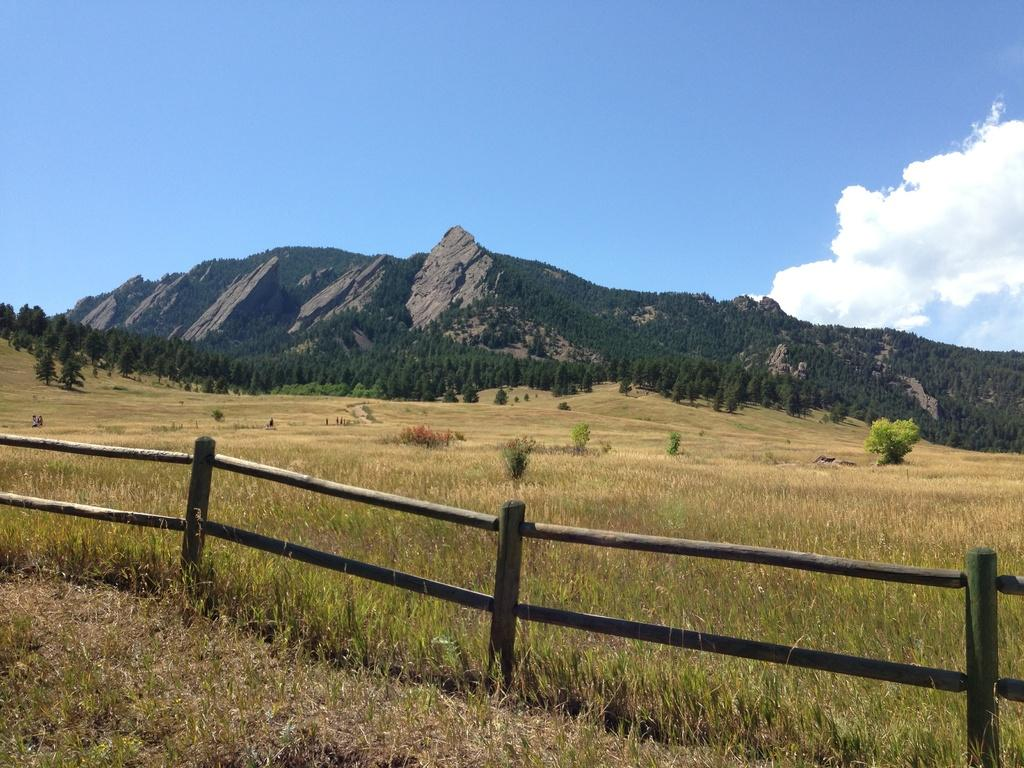What is located at the bottom of the image? There is a fence at the bottom of the image, and grass is also present there. What type of vegetation can be seen at the bottom of the image? Grass is present at the bottom of the image. What can be seen in the background of the image? Plants, trees, and mountains are visible in the background of the image. What is visible at the top of the image? The sky is visible at the top of the image. What type of collar can be seen on the mountain in the image? There is no collar present on the mountain in the image; it is a natural formation. What scientific theory is being demonstrated in the image? There is no scientific theory being demonstrated in the image; it is a landscape scene. 